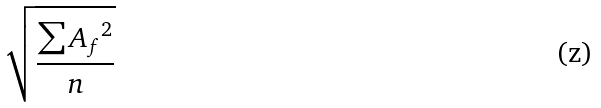<formula> <loc_0><loc_0><loc_500><loc_500>\sqrt { \frac { \sum { A _ { f } } ^ { 2 } } { n } }</formula> 